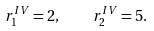<formula> <loc_0><loc_0><loc_500><loc_500>r _ { 1 } ^ { I V } = 2 , \quad r _ { 2 } ^ { I V } = 5 .</formula> 